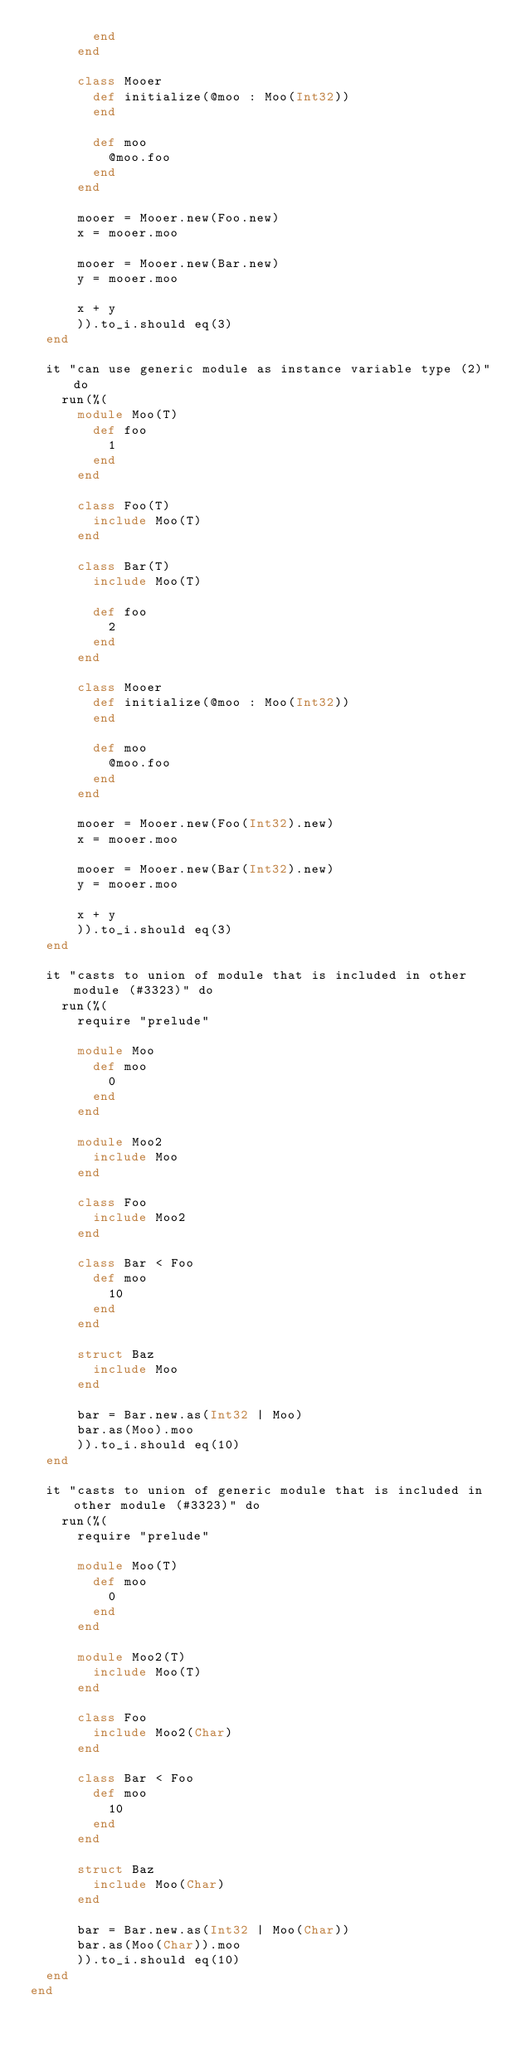<code> <loc_0><loc_0><loc_500><loc_500><_Crystal_>        end
      end

      class Mooer
        def initialize(@moo : Moo(Int32))
        end

        def moo
          @moo.foo
        end
      end

      mooer = Mooer.new(Foo.new)
      x = mooer.moo

      mooer = Mooer.new(Bar.new)
      y = mooer.moo

      x + y
      )).to_i.should eq(3)
  end

  it "can use generic module as instance variable type (2)" do
    run(%(
      module Moo(T)
        def foo
          1
        end
      end

      class Foo(T)
        include Moo(T)
      end

      class Bar(T)
        include Moo(T)

        def foo
          2
        end
      end

      class Mooer
        def initialize(@moo : Moo(Int32))
        end

        def moo
          @moo.foo
        end
      end

      mooer = Mooer.new(Foo(Int32).new)
      x = mooer.moo

      mooer = Mooer.new(Bar(Int32).new)
      y = mooer.moo

      x + y
      )).to_i.should eq(3)
  end

  it "casts to union of module that is included in other module (#3323)" do
    run(%(
      require "prelude"

      module Moo
        def moo
          0
        end
      end

      module Moo2
        include Moo
      end

      class Foo
        include Moo2
      end

      class Bar < Foo
        def moo
          10
        end
      end

      struct Baz
        include Moo
      end

      bar = Bar.new.as(Int32 | Moo)
      bar.as(Moo).moo
      )).to_i.should eq(10)
  end

  it "casts to union of generic module that is included in other module (#3323)" do
    run(%(
      require "prelude"

      module Moo(T)
        def moo
          0
        end
      end

      module Moo2(T)
        include Moo(T)
      end

      class Foo
        include Moo2(Char)
      end

      class Bar < Foo
        def moo
          10
        end
      end

      struct Baz
        include Moo(Char)
      end

      bar = Bar.new.as(Int32 | Moo(Char))
      bar.as(Moo(Char)).moo
      )).to_i.should eq(10)
  end
end
</code> 